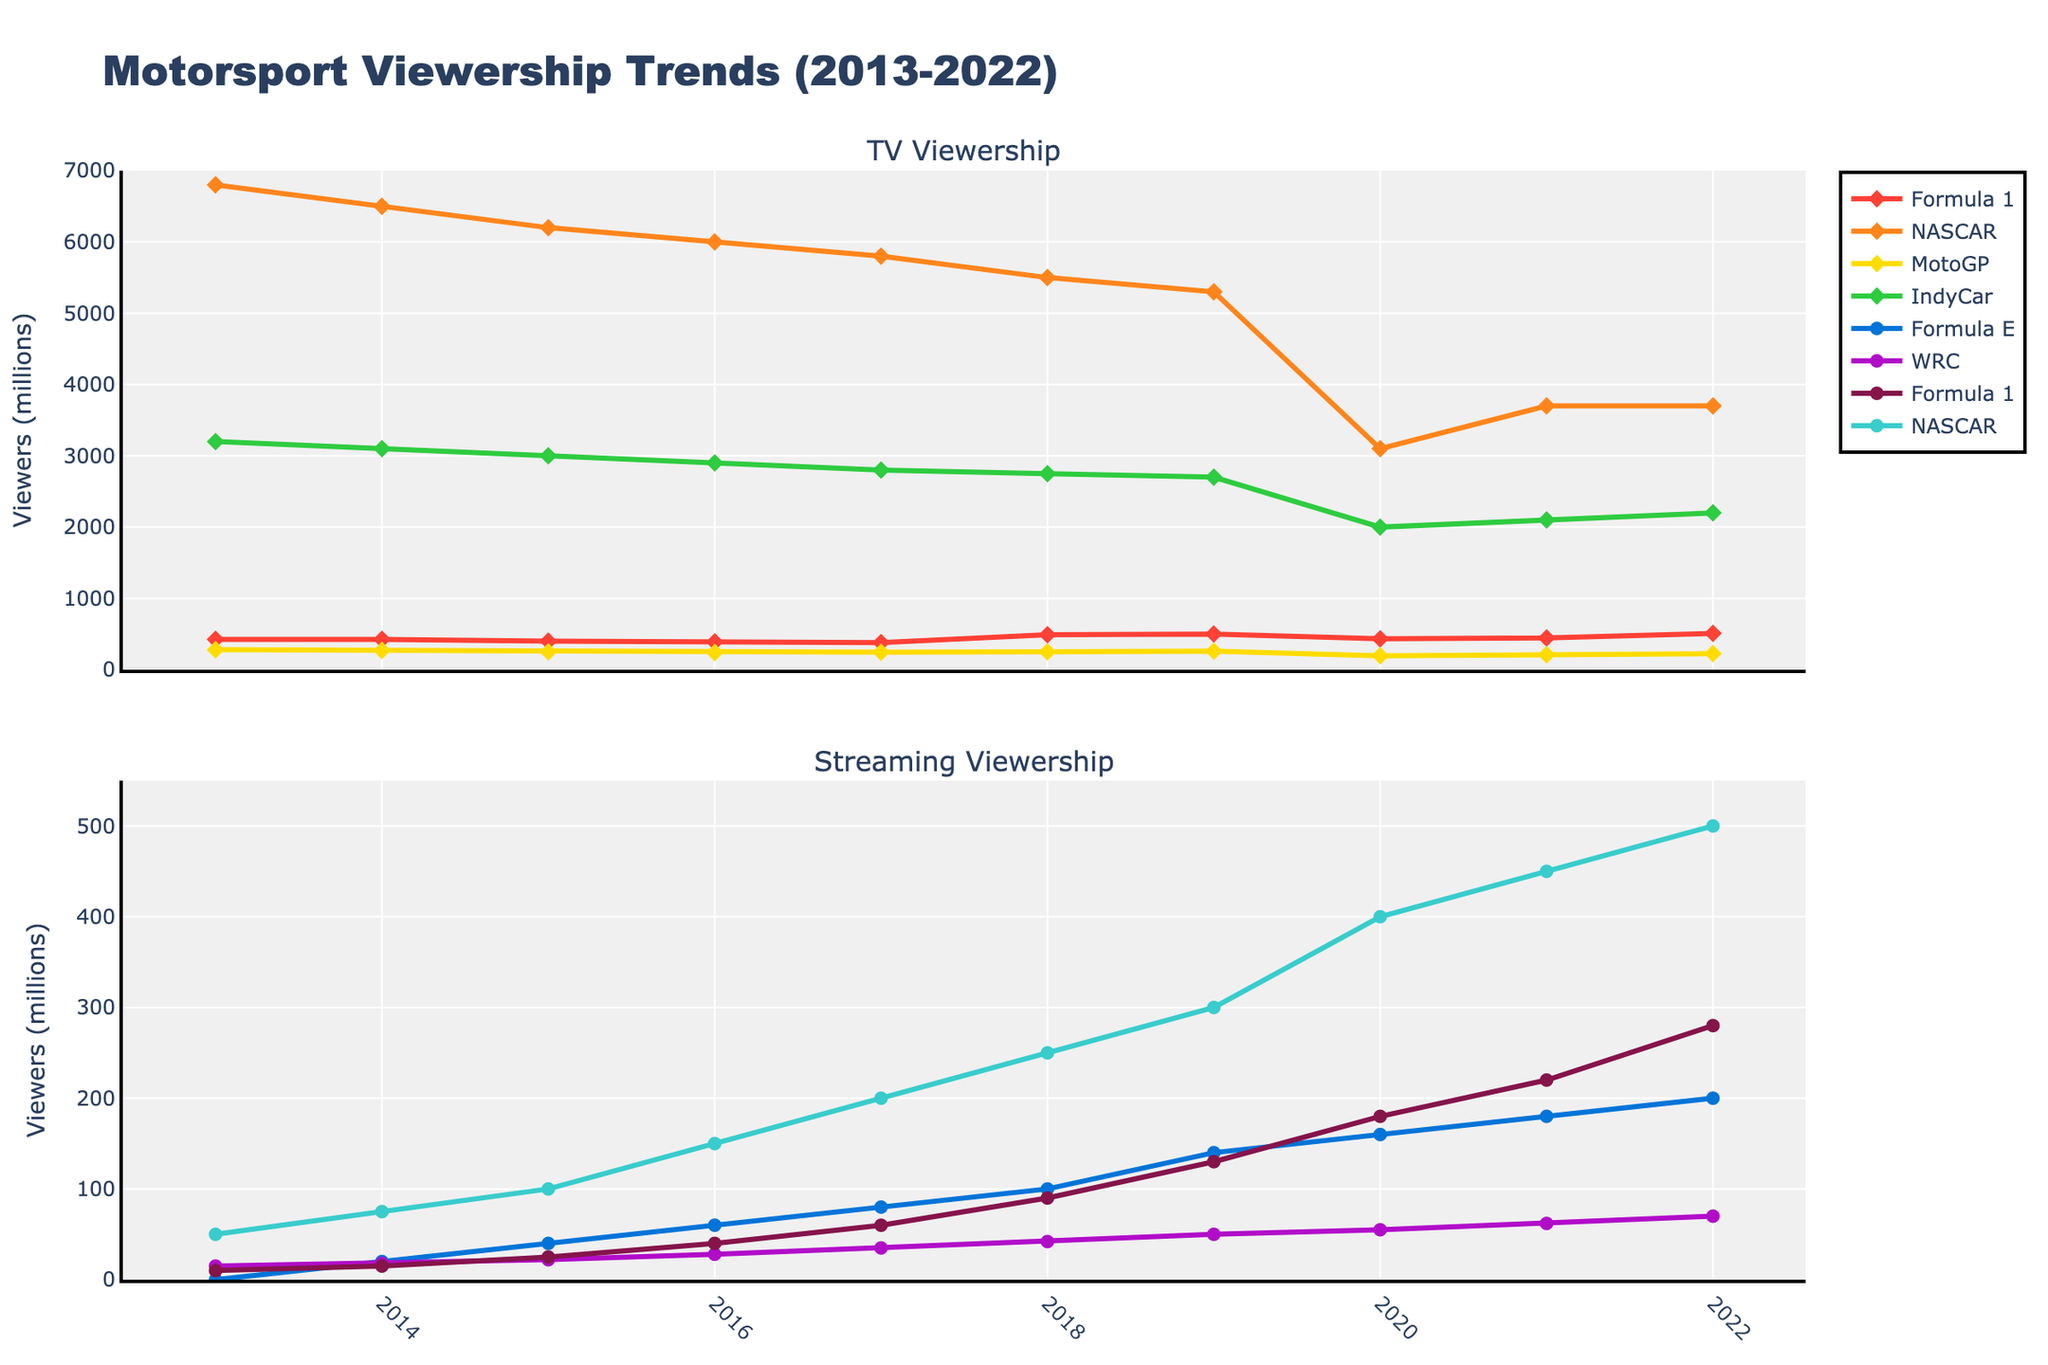What's the highest TV viewership recorded for Formula 1 over the past decade? The highest TV viewership for Formula 1 can be identified by looking at the peak point in the top subplot's line marked in red for Formula 1 (TV). This peak occurs in the year 2022 with a value of 510 million viewers.
Answer: 510 million Which year did MotoGP (TV) have the lowest viewership, and what was the value? To find this, look at the orange line in the top subplot for MotoGP (TV) and identify the lowest point. The lowest viewership occurred in 2020 with a value of 195 million viewers.
Answer: 2020, 195 million Compare the TV viewership trend of NASCAR and Formula 1 from 2018 to 2022. Which one had a more significant decline or increase in viewership? To compare, look at the teal line for NASCAR (TV) and the red line for Formula 1 (TV) in the top subplot from 2018 to 2022. NASCAR remained constant at 3700 million viewers, while Formula 1 increased from 490 to 510 million viewers. Formula 1 had an increase while NASCAR remained unchanged.
Answer: Formula 1 increased, NASCAR remained unchanged What is the difference between Formula E’s streaming viewership in 2020 and 2021? Locate the green line in the bottom subplot for Formula E (Streaming) and find the values for 2020 and 2021. In 2020, the viewers were 160 million, and in 2021, they were 180 million. The difference is 180 - 160 = 20 million viewers.
Answer: 20 million During which year did the combined streaming viewership of Formula 1 and NASCAR exceed 600 million viewers? To determine this, sum the blue line for Formula 1 (Streaming) and the cyan line for NASCAR (Streaming) in the bottom subplot for each year. In 2022, Formula 1 had 280 million viewers and NASCAR had 500 million, summing up to 780 million viewers, which exceeds 600 million.
Answer: 2022 